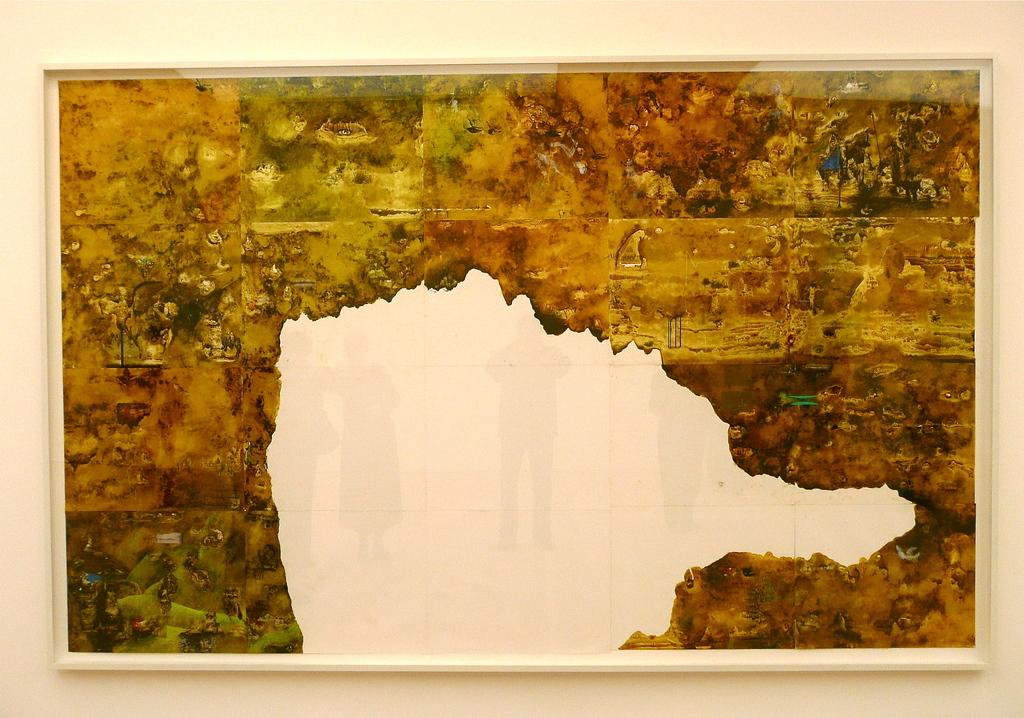What colors are used in the frame of the image? The frame in the image is in white, yellow, and orange colors. Can you see any sheep grazing in the afternoon near the frame in the image? There is no reference to sheep, grazing, or afternoon in the image, so it is not possible to answer that question. 